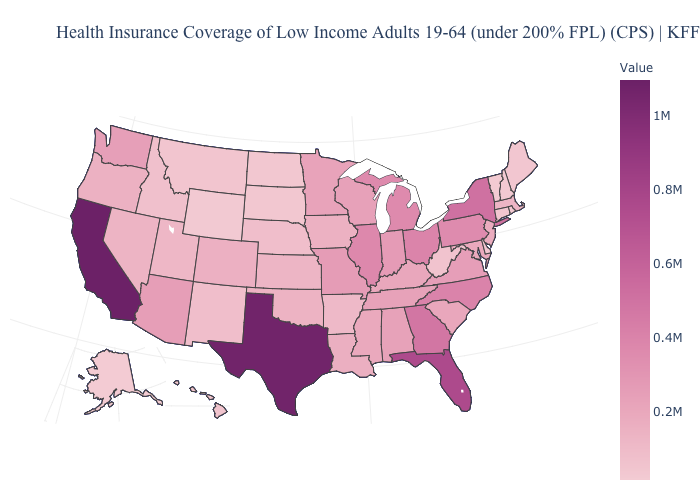Does North Dakota have a higher value than Indiana?
Write a very short answer. No. Which states have the lowest value in the USA?
Keep it brief. Alaska. Among the states that border Arkansas , which have the lowest value?
Be succinct. Oklahoma. Among the states that border Ohio , which have the highest value?
Keep it brief. Michigan. Does Vermont have the lowest value in the Northeast?
Quick response, please. Yes. Which states have the highest value in the USA?
Concise answer only. California. 